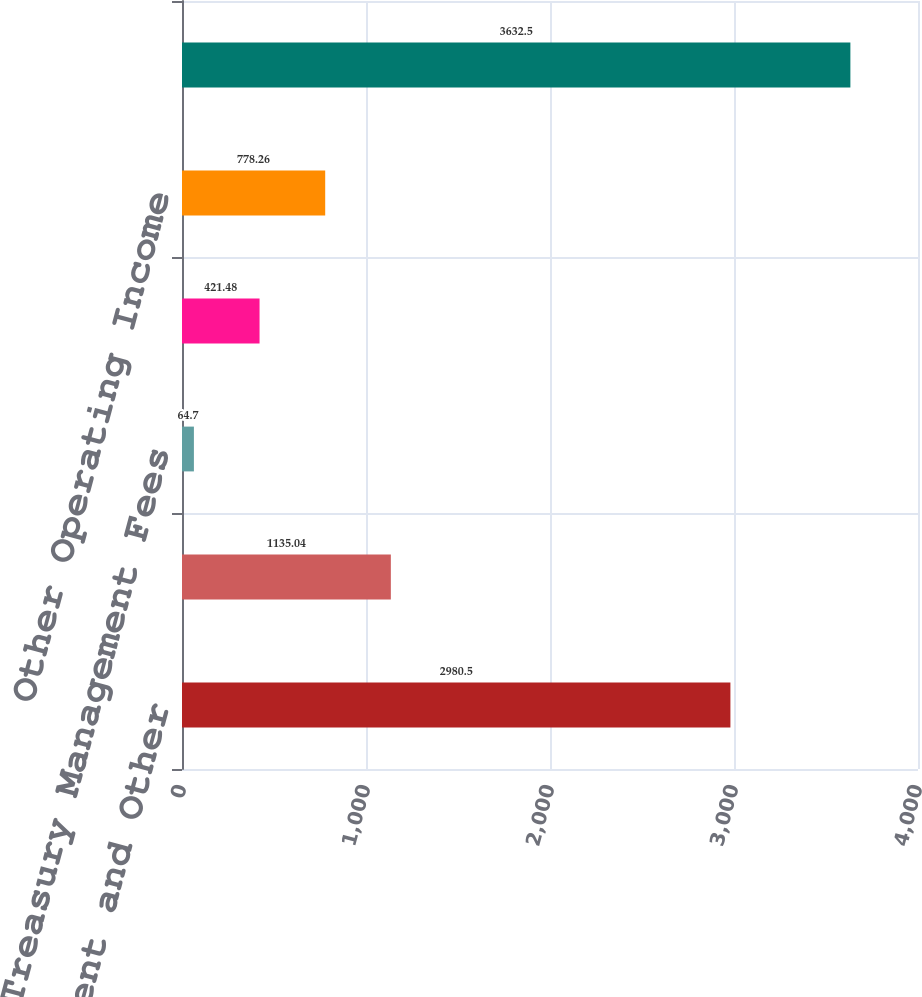Convert chart. <chart><loc_0><loc_0><loc_500><loc_500><bar_chart><fcel>Trust Investment and Other<fcel>Foreign Exchange Trading<fcel>Treasury Management Fees<fcel>Security Commissions and<fcel>Other Operating Income<fcel>Total Noninterest Income<nl><fcel>2980.5<fcel>1135.04<fcel>64.7<fcel>421.48<fcel>778.26<fcel>3632.5<nl></chart> 